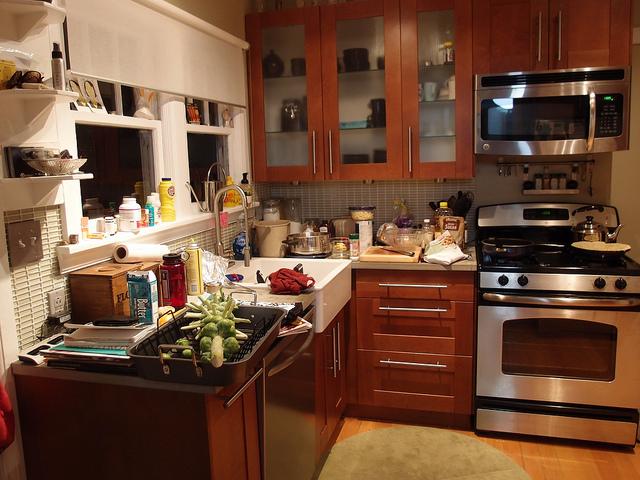Could this kitchen be commercial?
Be succinct. No. Where is the kettle?
Give a very brief answer. On stove. Where is the microwave?
Be succinct. Above stove. Are the ovens the same color?
Short answer required. Yes. Is the oven turned on?
Give a very brief answer. No. What side of the stove top is the tea kettle on?
Quick response, please. Right. 